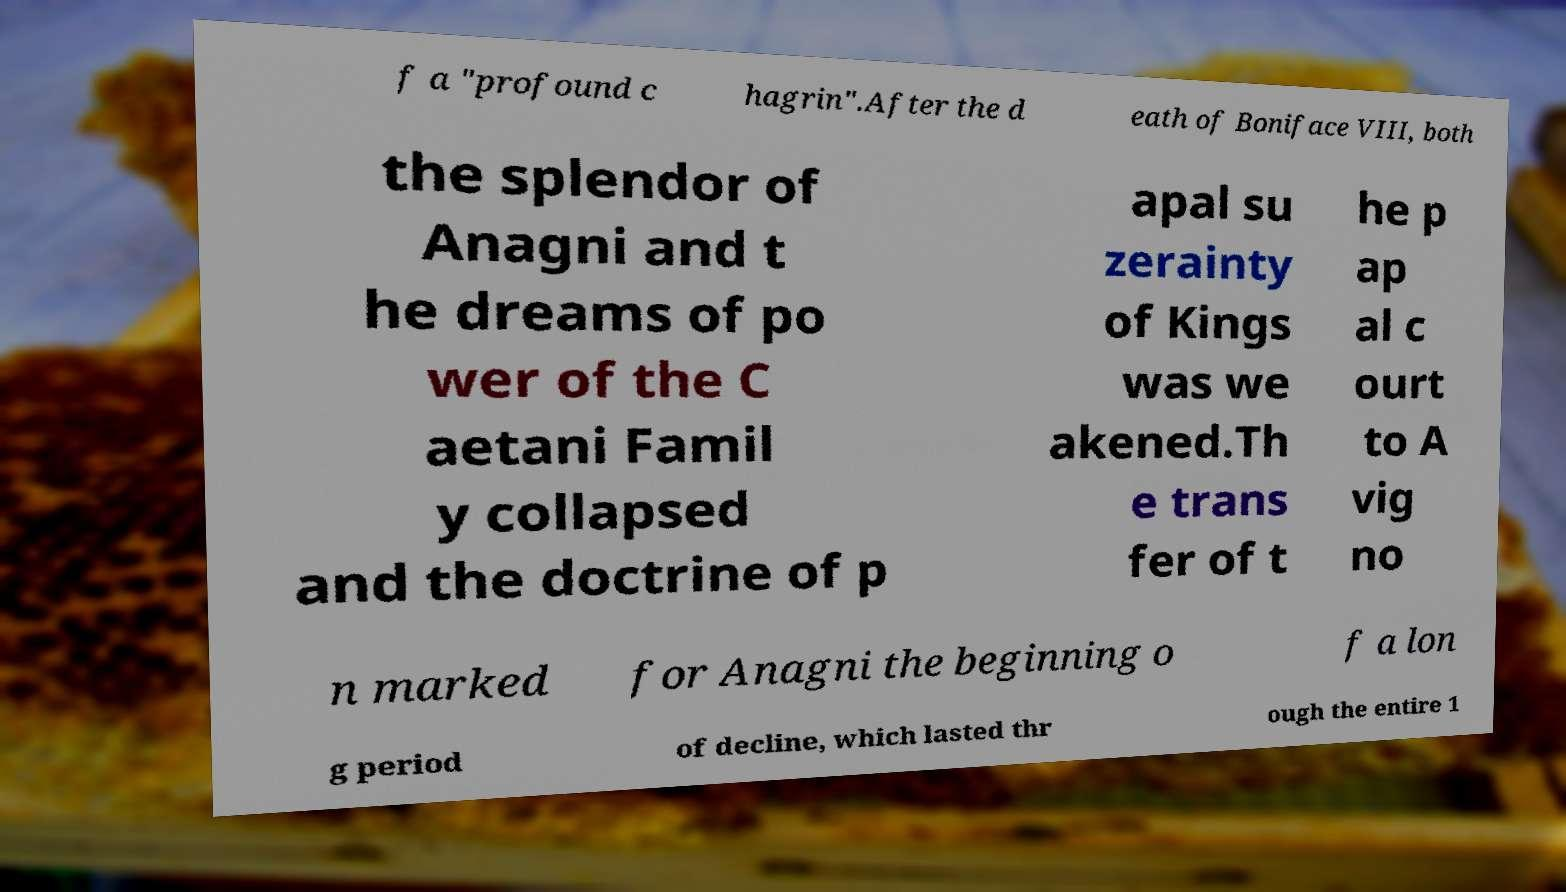For documentation purposes, I need the text within this image transcribed. Could you provide that? f a "profound c hagrin".After the d eath of Boniface VIII, both the splendor of Anagni and t he dreams of po wer of the C aetani Famil y collapsed and the doctrine of p apal su zerainty of Kings was we akened.Th e trans fer of t he p ap al c ourt to A vig no n marked for Anagni the beginning o f a lon g period of decline, which lasted thr ough the entire 1 